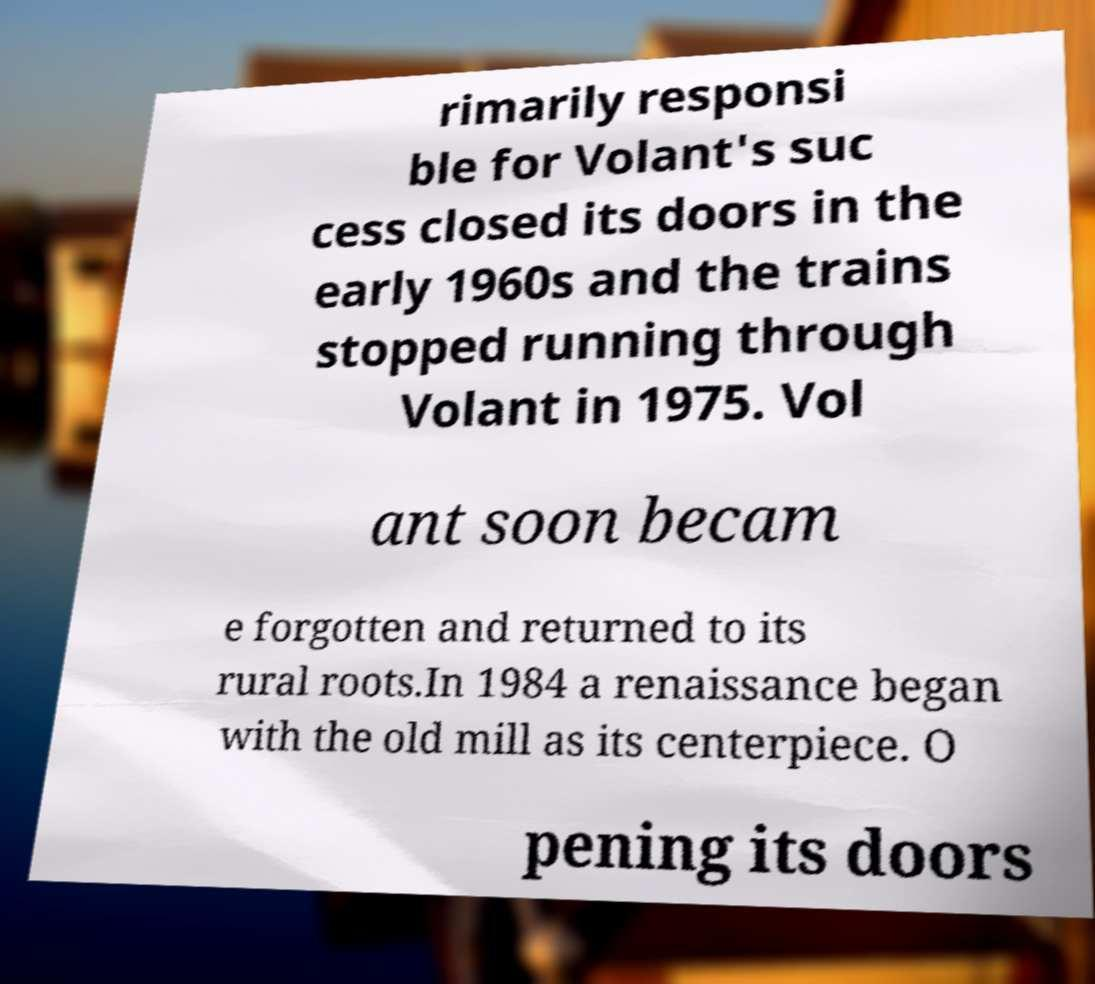For documentation purposes, I need the text within this image transcribed. Could you provide that? rimarily responsi ble for Volant's suc cess closed its doors in the early 1960s and the trains stopped running through Volant in 1975. Vol ant soon becam e forgotten and returned to its rural roots.In 1984 a renaissance began with the old mill as its centerpiece. O pening its doors 